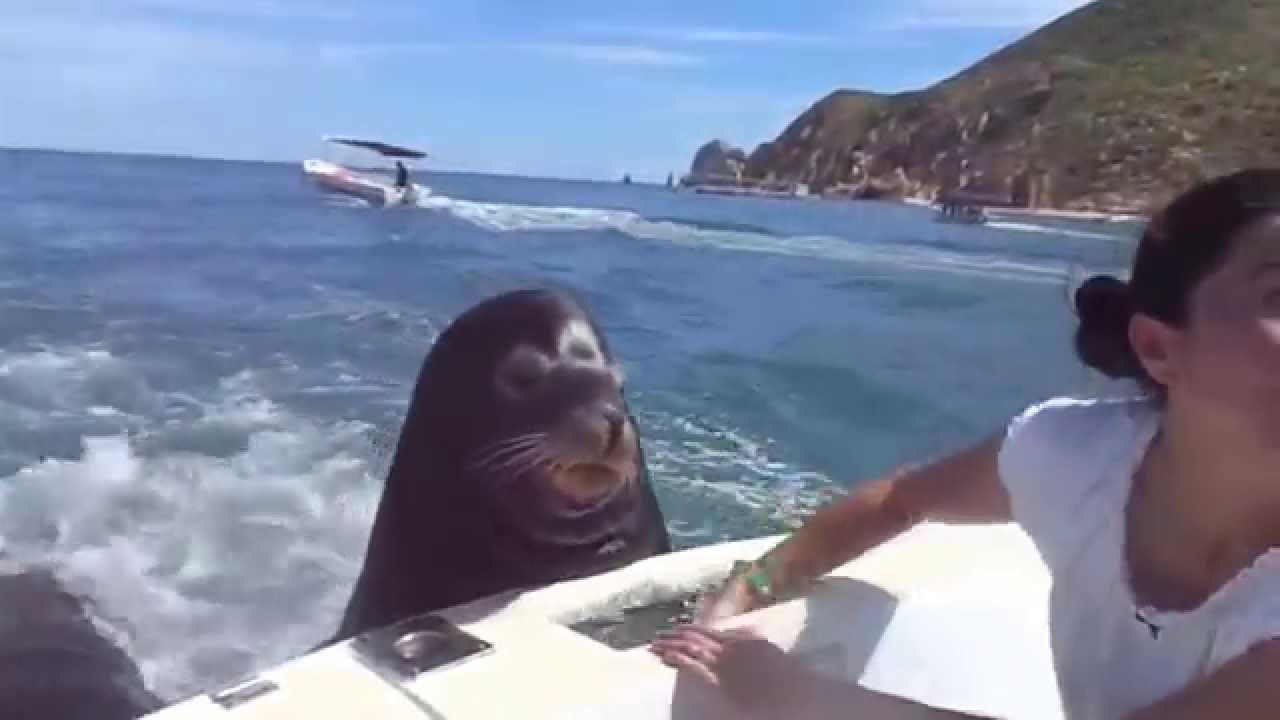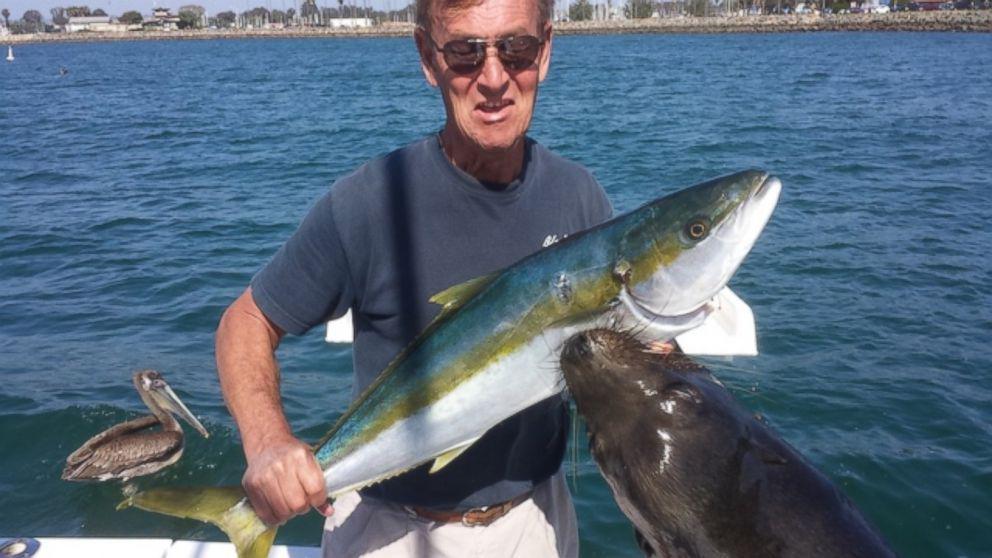The first image is the image on the left, the second image is the image on the right. Considering the images on both sides, is "The right image contains a person holding a fish." valid? Answer yes or no. Yes. The first image is the image on the left, the second image is the image on the right. Evaluate the accuracy of this statement regarding the images: "A sea lion is looking over a boat where a woman sits.". Is it true? Answer yes or no. Yes. 